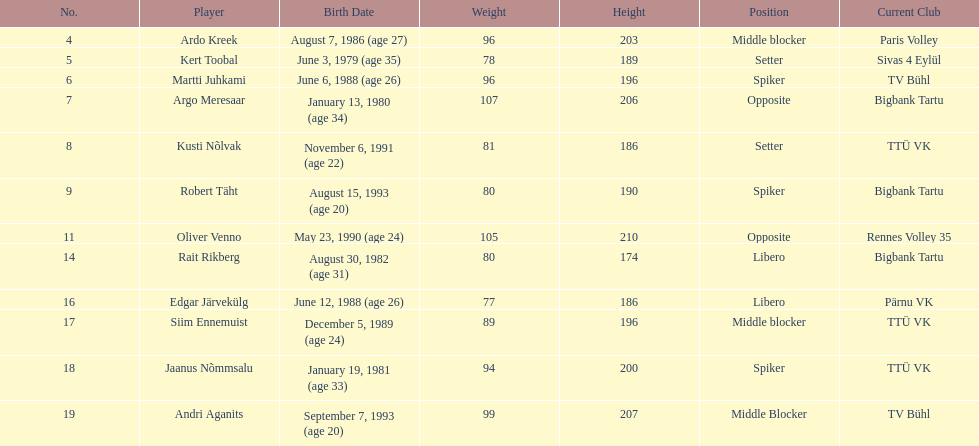How many players are middle blockers? 3. 